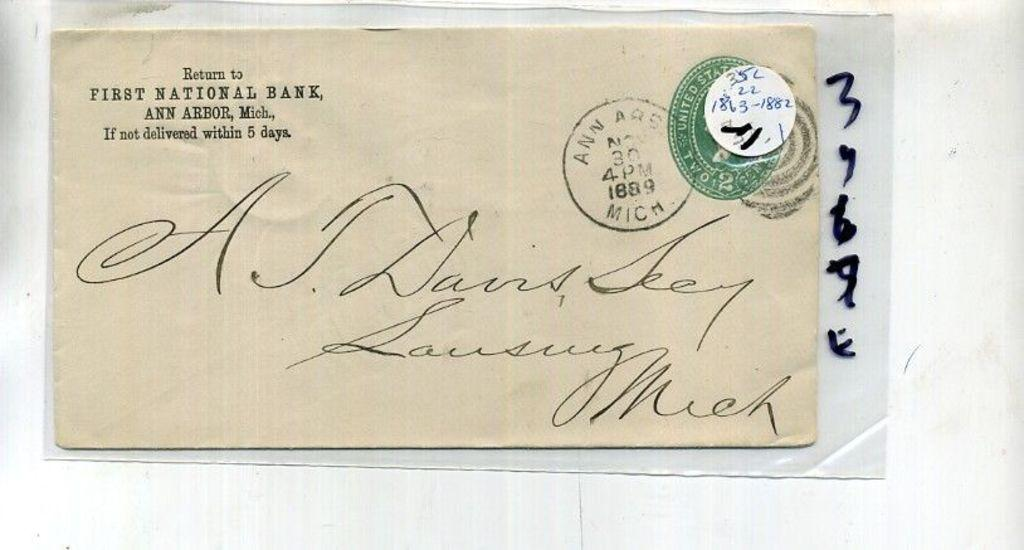<image>
Write a terse but informative summary of the picture. an old envelope has words Return to First National Bank on the upper left corner 